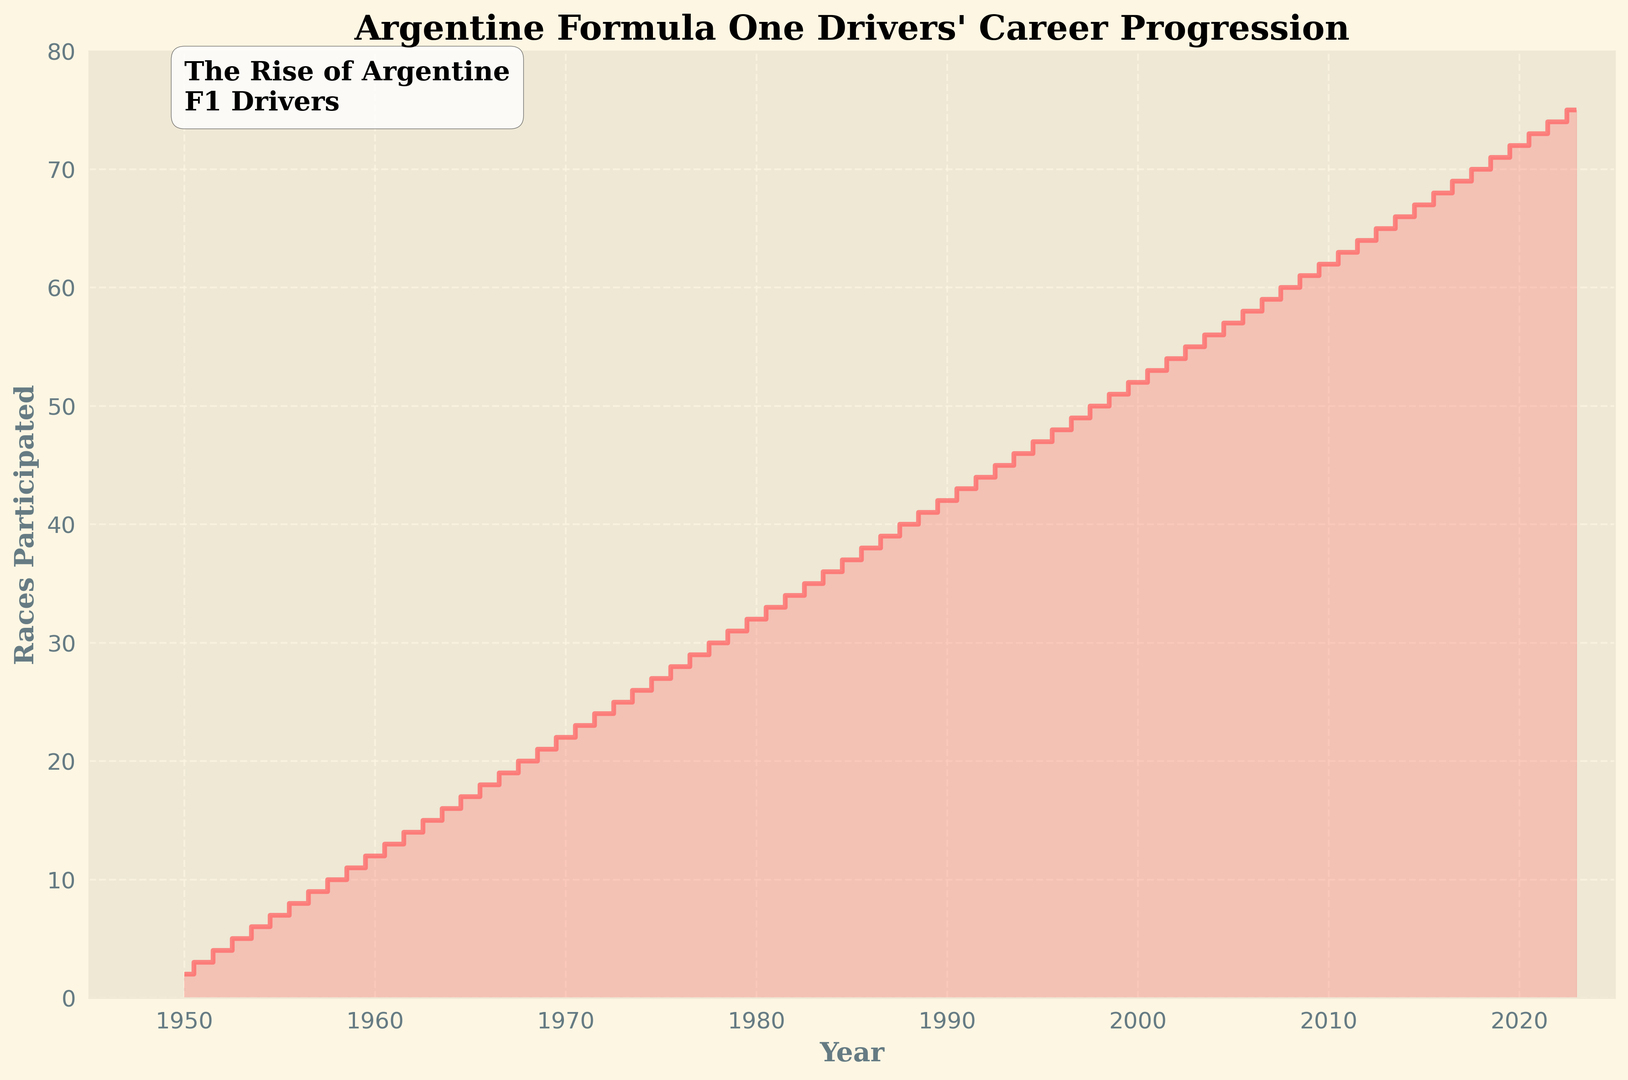how many races were participated in 1970? Locate the year 1970 on the x-axis, then follow vertically to the step representing the number of races in that year. The step corresponds to 22 races.
Answer: 22 which year saw the largest increase in races participated compared to the previous year? Look for the steepest steps in the plot where the difference between consecutive years is the largest. Each year’s progression is consistently incremental by 1 race. So there isn't one particular year with an unusually large increase compared to others.
Answer: None what’s the difference in races between 1990 and 2000? Locate the years 1990 and 2000 on the x-axis, then follow vertically to their respective values on the y-axis. Subtract the number of races in 1990 (42 races) from the number of races in 2000 (52 races). The difference is 52 - 42 = 10 races.
Answer: 10 how many races were participated altogether from 1950 to 1960 inclusive? Sum the values for each year from 1950 (2 races) to 1960 (12 races). This is 2 + 3 + 4 + 5 + 6 + 7 + 8 + 9 + 10 + 11 + 12 = 77 races.
Answer: 77 during which decade did the number of races increase by exactly 10 races? Check the cumulative increase for each decade. For example, between 1950 to 1960, it increased from 2 to 12 races, which is an increase of 10 races. Similarly, other decades must be checked but 1950-1960 has an exact increase by 10 races.
Answer: 1950-1960 how many more races were participated in 2023 compared to 1950? Locate the values for 2023 and 1950 on the chart. In 2023, there were 75 races; in 1950, there were 2 races. The difference is 75 - 2 = 73 races.
Answer: 73 what's the average number of races participated per year from 2010 to 2020? Sum the values for each year from 2010 to 2020, then divide by the number of years. For 2010 (62), 2011 (63), 2012 (64), 2013 (65), 2014 (66), 2015 (67), 2016 (68), 2017 (69), 2018 (70), 2019 (71), 2020 (72): (62 + 63 + 64 + 65 + 66 + 67 + 68 + 69 + 70 + 71 + 72) = 737. Divide by 11 years: 737 / 11 ≈ 67.
Answer: 67 